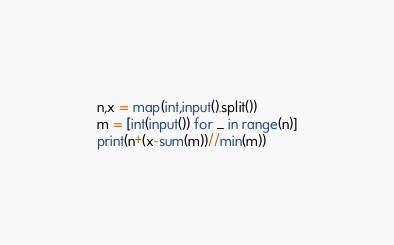<code> <loc_0><loc_0><loc_500><loc_500><_Python_>n,x = map(int,input().split())
m = [int(input()) for _ in range(n)]
print(n+(x-sum(m))//min(m))</code> 